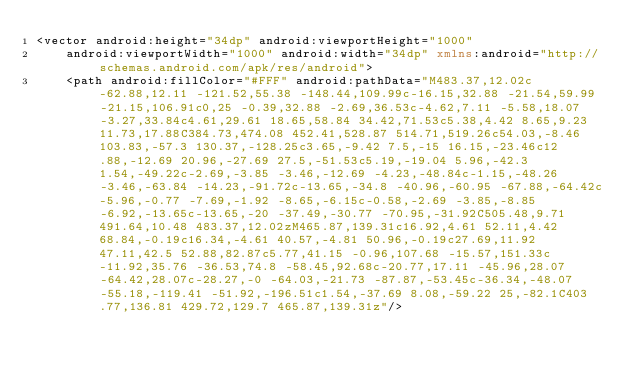<code> <loc_0><loc_0><loc_500><loc_500><_XML_><vector android:height="34dp" android:viewportHeight="1000"
    android:viewportWidth="1000" android:width="34dp" xmlns:android="http://schemas.android.com/apk/res/android">
    <path android:fillColor="#FFF" android:pathData="M483.37,12.02c-62.88,12.11 -121.52,55.38 -148.44,109.99c-16.15,32.88 -21.54,59.99 -21.15,106.91c0,25 -0.39,32.88 -2.69,36.53c-4.62,7.11 -5.58,18.07 -3.27,33.84c4.61,29.61 18.65,58.84 34.42,71.53c5.38,4.42 8.65,9.23 11.73,17.88C384.73,474.08 452.41,528.87 514.71,519.26c54.03,-8.46 103.83,-57.3 130.37,-128.25c3.65,-9.42 7.5,-15 16.15,-23.46c12.88,-12.69 20.96,-27.69 27.5,-51.53c5.19,-19.04 5.96,-42.3 1.54,-49.22c-2.69,-3.85 -3.46,-12.69 -4.23,-48.84c-1.15,-48.26 -3.46,-63.84 -14.23,-91.72c-13.65,-34.8 -40.96,-60.95 -67.88,-64.42c-5.96,-0.77 -7.69,-1.92 -8.65,-6.15c-0.58,-2.69 -3.85,-8.85 -6.92,-13.65c-13.65,-20 -37.49,-30.77 -70.95,-31.92C505.48,9.71 491.64,10.48 483.37,12.02zM465.87,139.31c16.92,4.61 52.11,4.42 68.84,-0.19c16.34,-4.61 40.57,-4.81 50.96,-0.19c27.69,11.92 47.11,42.5 52.88,82.87c5.77,41.15 -0.96,107.68 -15.57,151.33c-11.92,35.76 -36.53,74.8 -58.45,92.68c-20.77,17.11 -45.96,28.07 -64.42,28.07c-28.27,-0 -64.03,-21.73 -87.87,-53.45c-36.34,-48.07 -55.18,-119.41 -51.92,-196.51c1.54,-37.69 8.08,-59.22 25,-82.1C403.77,136.81 429.72,129.7 465.87,139.31z"/></code> 